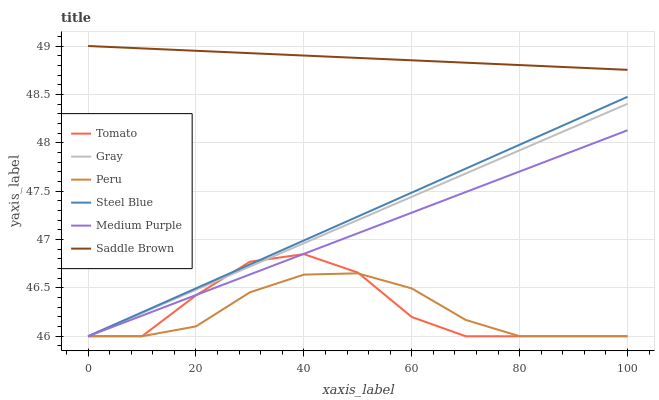Does Peru have the minimum area under the curve?
Answer yes or no. Yes. Does Saddle Brown have the maximum area under the curve?
Answer yes or no. Yes. Does Gray have the minimum area under the curve?
Answer yes or no. No. Does Gray have the maximum area under the curve?
Answer yes or no. No. Is Medium Purple the smoothest?
Answer yes or no. Yes. Is Tomato the roughest?
Answer yes or no. Yes. Is Gray the smoothest?
Answer yes or no. No. Is Gray the roughest?
Answer yes or no. No. Does Saddle Brown have the lowest value?
Answer yes or no. No. Does Saddle Brown have the highest value?
Answer yes or no. Yes. Does Gray have the highest value?
Answer yes or no. No. Is Medium Purple less than Saddle Brown?
Answer yes or no. Yes. Is Saddle Brown greater than Peru?
Answer yes or no. Yes. Does Peru intersect Tomato?
Answer yes or no. Yes. Is Peru less than Tomato?
Answer yes or no. No. Is Peru greater than Tomato?
Answer yes or no. No. Does Medium Purple intersect Saddle Brown?
Answer yes or no. No. 